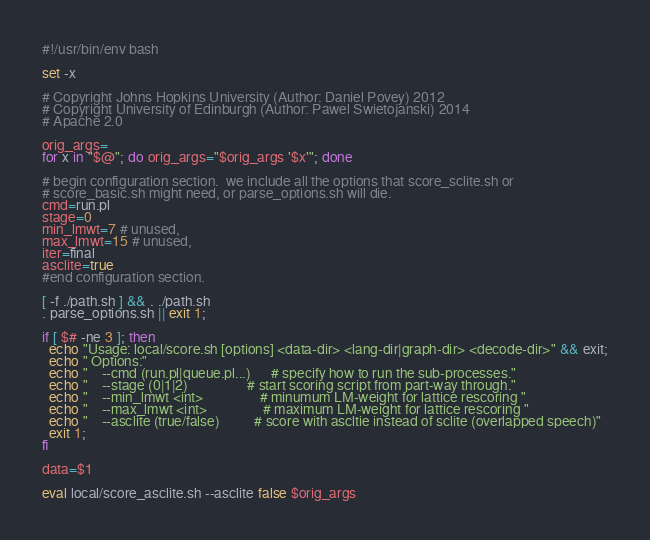<code> <loc_0><loc_0><loc_500><loc_500><_Bash_>#!/usr/bin/env bash

set -x

# Copyright Johns Hopkins University (Author: Daniel Povey) 2012
# Copyright University of Edinburgh (Author: Pawel Swietojanski) 2014
# Apache 2.0

orig_args=
for x in "$@"; do orig_args="$orig_args '$x'"; done

# begin configuration section.  we include all the options that score_sclite.sh or
# score_basic.sh might need, or parse_options.sh will die.
cmd=run.pl
stage=0
min_lmwt=7 # unused,
max_lmwt=15 # unused,
iter=final
asclite=true
#end configuration section.

[ -f ./path.sh ] && . ./path.sh
. parse_options.sh || exit 1;

if [ $# -ne 3 ]; then
  echo "Usage: local/score.sh [options] <data-dir> <lang-dir|graph-dir> <decode-dir>" && exit;
  echo " Options:"
  echo "    --cmd (run.pl|queue.pl...)      # specify how to run the sub-processes."
  echo "    --stage (0|1|2)                 # start scoring script from part-way through."
  echo "    --min_lmwt <int>                # minumum LM-weight for lattice rescoring "
  echo "    --max_lmwt <int>                # maximum LM-weight for lattice rescoring "
  echo "    --asclite (true/false)          # score with ascltie instead of sclite (overlapped speech)"
  exit 1;
fi

data=$1

eval local/score_asclite.sh --asclite false $orig_args

</code> 